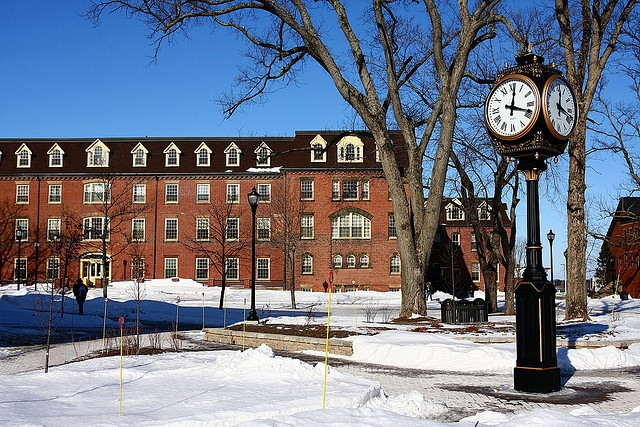Describe the objects in this image and their specific colors. I can see clock in blue, white, black, gray, and darkgray tones, clock in blue, black, darkgray, maroon, and lightgray tones, and people in blue, black, navy, maroon, and gray tones in this image. 